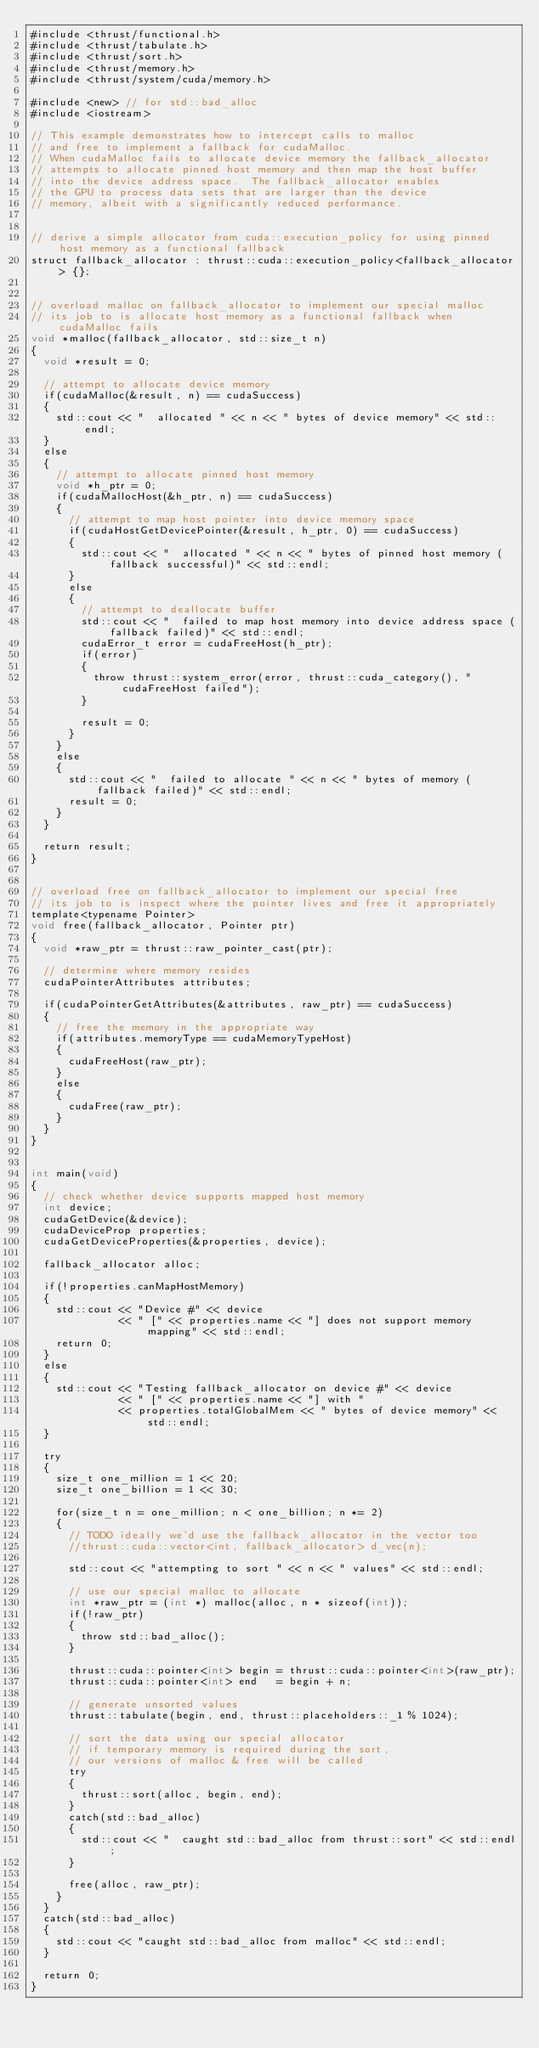<code> <loc_0><loc_0><loc_500><loc_500><_Cuda_>#include <thrust/functional.h>
#include <thrust/tabulate.h>
#include <thrust/sort.h>
#include <thrust/memory.h>
#include <thrust/system/cuda/memory.h>

#include <new> // for std::bad_alloc
#include <iostream>

// This example demonstrates how to intercept calls to malloc
// and free to implement a fallback for cudaMalloc.
// When cudaMalloc fails to allocate device memory the fallback_allocator
// attempts to allocate pinned host memory and then map the host buffer 
// into the device address space.  The fallback_allocator enables
// the GPU to process data sets that are larger than the device
// memory, albeit with a significantly reduced performance.


// derive a simple allocator from cuda::execution_policy for using pinned host memory as a functional fallback
struct fallback_allocator : thrust::cuda::execution_policy<fallback_allocator> {};


// overload malloc on fallback_allocator to implement our special malloc 
// its job to is allocate host memory as a functional fallback when cudaMalloc fails
void *malloc(fallback_allocator, std::size_t n)
{
  void *result = 0;

  // attempt to allocate device memory
  if(cudaMalloc(&result, n) == cudaSuccess)
  {
    std::cout << "  allocated " << n << " bytes of device memory" << std::endl;
  }
  else
  {
    // attempt to allocate pinned host memory
    void *h_ptr = 0;
    if(cudaMallocHost(&h_ptr, n) == cudaSuccess)
    {
      // attempt to map host pointer into device memory space
      if(cudaHostGetDevicePointer(&result, h_ptr, 0) == cudaSuccess)
      {
        std::cout << "  allocated " << n << " bytes of pinned host memory (fallback successful)" << std::endl;
      }
      else
      {
        // attempt to deallocate buffer
        std::cout << "  failed to map host memory into device address space (fallback failed)" << std::endl;
        cudaError_t error = cudaFreeHost(h_ptr);
        if(error)
        {
          throw thrust::system_error(error, thrust::cuda_category(), "cudaFreeHost failed");
        }

        result = 0;
      }
    }
    else
    {
      std::cout << "  failed to allocate " << n << " bytes of memory (fallback failed)" << std::endl;
      result = 0;
    }
  }

  return result;
}


// overload free on fallback_allocator to implement our special free 
// its job to is inspect where the pointer lives and free it appropriately
template<typename Pointer>
void free(fallback_allocator, Pointer ptr)
{
  void *raw_ptr = thrust::raw_pointer_cast(ptr);

  // determine where memory resides
  cudaPointerAttributes	attributes;

  if(cudaPointerGetAttributes(&attributes, raw_ptr) == cudaSuccess)
  {
    // free the memory in the appropriate way
    if(attributes.memoryType == cudaMemoryTypeHost)
    {
      cudaFreeHost(raw_ptr);
    }
    else
    {
      cudaFree(raw_ptr);
    }
  }
}


int main(void)
{
  // check whether device supports mapped host memory
  int device;
  cudaGetDevice(&device);
  cudaDeviceProp properties;
  cudaGetDeviceProperties(&properties, device);

  fallback_allocator alloc;

  if(!properties.canMapHostMemory)
  {
    std::cout << "Device #" << device 
              << " [" << properties.name << "] does not support memory mapping" << std::endl;
    return 0;
  }
  else
  {
    std::cout << "Testing fallback_allocator on device #" << device 
              << " [" << properties.name << "] with " 
              << properties.totalGlobalMem << " bytes of device memory" << std::endl;
  }

  try
  {
    size_t one_million = 1 << 20;
    size_t one_billion = 1 << 30;

    for(size_t n = one_million; n < one_billion; n *= 2)
    {
      // TODO ideally we'd use the fallback_allocator in the vector too
      //thrust::cuda::vector<int, fallback_allocator> d_vec(n);

      std::cout << "attempting to sort " << n << " values" << std::endl;

      // use our special malloc to allocate
      int *raw_ptr = (int *) malloc(alloc, n * sizeof(int));
      if(!raw_ptr)
      {
        throw std::bad_alloc();
      }

      thrust::cuda::pointer<int> begin = thrust::cuda::pointer<int>(raw_ptr);
      thrust::cuda::pointer<int> end   = begin + n;

      // generate unsorted values
      thrust::tabulate(begin, end, thrust::placeholders::_1 % 1024);

      // sort the data using our special allocator
      // if temporary memory is required during the sort,
      // our versions of malloc & free will be called
      try
      {
        thrust::sort(alloc, begin, end);
      }
      catch(std::bad_alloc)
      {
        std::cout << "  caught std::bad_alloc from thrust::sort" << std::endl;
      }

      free(alloc, raw_ptr);
    }
  }
  catch(std::bad_alloc)
  {
    std::cout << "caught std::bad_alloc from malloc" << std::endl;
  }

  return 0;
}

</code> 